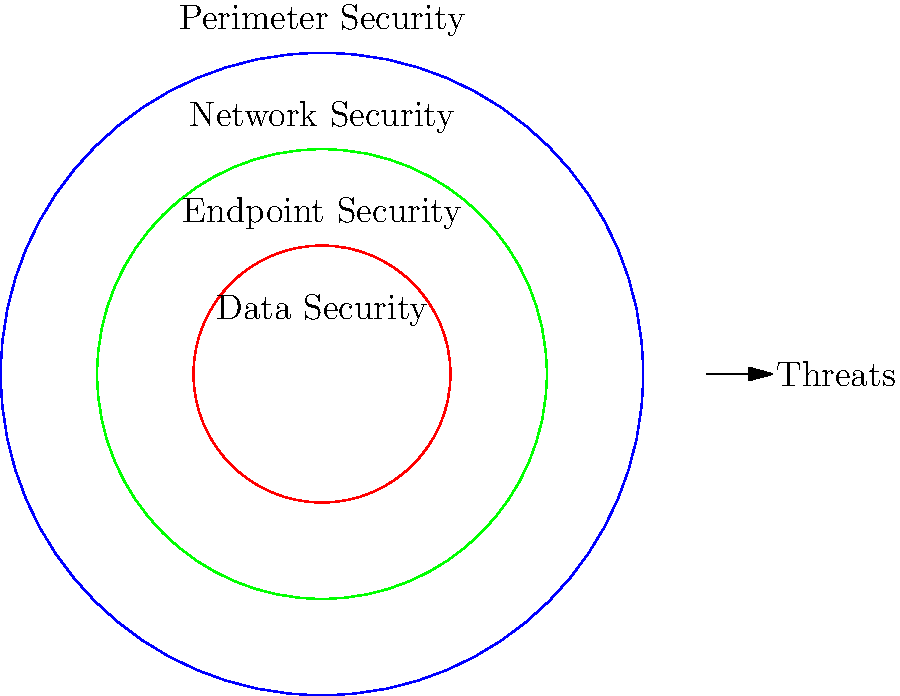In the defense-in-depth model shown, which layer of security would be the first to encounter and potentially mitigate an incoming network-based threat? To answer this question, we need to understand the defense-in-depth model and how it's represented in the diagram:

1. The defense-in-depth model is a layered approach to cybersecurity, where multiple security measures are used to protect an organization's assets.

2. In the diagram, we see concentric circles representing different security layers:
   - The outermost circle (blue) represents Perimeter Security
   - The middle circle (green) represents Network Security
   - The inner circle (red) represents Endpoint Security
   - The center represents Data Security

3. The arrow on the right side of the diagram indicates the direction of incoming threats.

4. In a defense-in-depth model, threats are typically encountered and mitigated from the outside in. This means that the outermost layer of security is the first line of defense against incoming threats.

5. Therefore, the first layer to encounter and potentially mitigate an incoming network-based threat would be the outermost circle, which represents Perimeter Security.

Perimeter Security typically includes measures such as firewalls, intrusion detection/prevention systems (IDS/IPS), and virtual private networks (VPNs) that form the boundary between an organization's internal network and the external world.
Answer: Perimeter Security 